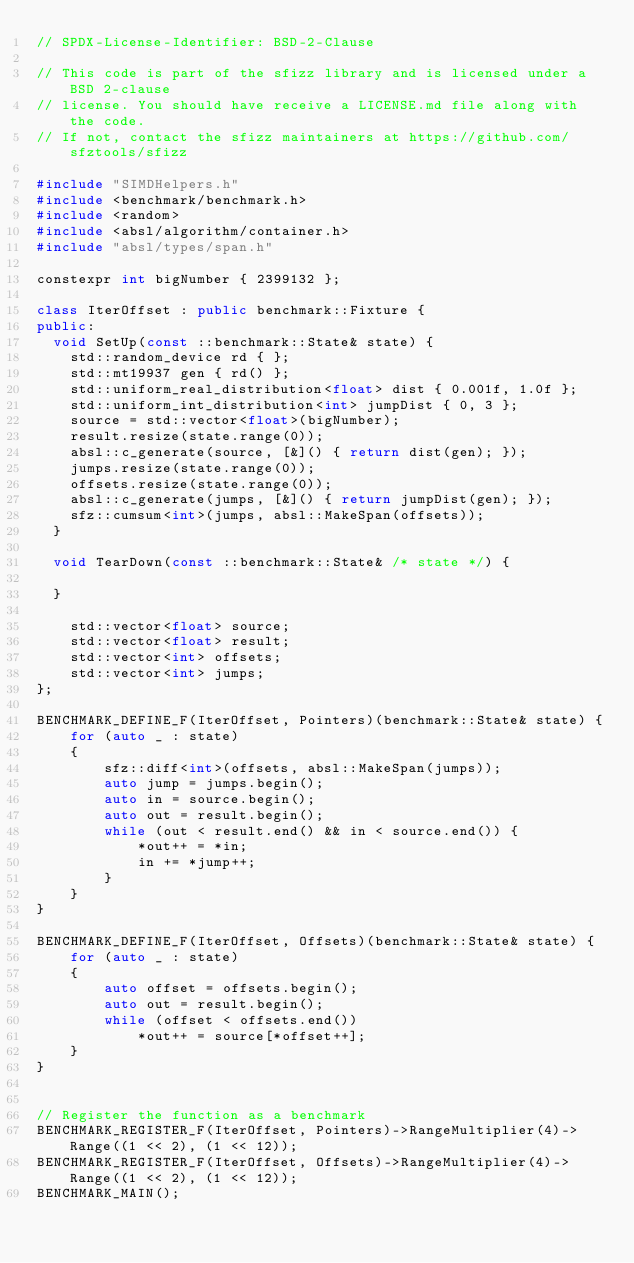<code> <loc_0><loc_0><loc_500><loc_500><_C++_>// SPDX-License-Identifier: BSD-2-Clause

// This code is part of the sfizz library and is licensed under a BSD 2-clause
// license. You should have receive a LICENSE.md file along with the code.
// If not, contact the sfizz maintainers at https://github.com/sfztools/sfizz

#include "SIMDHelpers.h"
#include <benchmark/benchmark.h>
#include <random>
#include <absl/algorithm/container.h>
#include "absl/types/span.h"

constexpr int bigNumber { 2399132 };

class IterOffset : public benchmark::Fixture {
public:
  void SetUp(const ::benchmark::State& state) {
    std::random_device rd { };
    std::mt19937 gen { rd() };
    std::uniform_real_distribution<float> dist { 0.001f, 1.0f };
    std::uniform_int_distribution<int> jumpDist { 0, 3 };
    source = std::vector<float>(bigNumber);
    result.resize(state.range(0));
    absl::c_generate(source, [&]() { return dist(gen); });
    jumps.resize(state.range(0));
    offsets.resize(state.range(0));
    absl::c_generate(jumps, [&]() { return jumpDist(gen); });
    sfz::cumsum<int>(jumps, absl::MakeSpan(offsets));
  }

  void TearDown(const ::benchmark::State& /* state */) {

  }

    std::vector<float> source;
    std::vector<float> result;
    std::vector<int> offsets;
    std::vector<int> jumps;
};

BENCHMARK_DEFINE_F(IterOffset, Pointers)(benchmark::State& state) {
    for (auto _ : state)
    {
        sfz::diff<int>(offsets, absl::MakeSpan(jumps));
        auto jump = jumps.begin();
        auto in = source.begin();
        auto out = result.begin();
        while (out < result.end() && in < source.end()) {
            *out++ = *in;
            in += *jump++;
        }
    }
}

BENCHMARK_DEFINE_F(IterOffset, Offsets)(benchmark::State& state) {
    for (auto _ : state)
    {
        auto offset = offsets.begin();
        auto out = result.begin();
        while (offset < offsets.end())
            *out++ = source[*offset++];
    }
}


// Register the function as a benchmark
BENCHMARK_REGISTER_F(IterOffset, Pointers)->RangeMultiplier(4)->Range((1 << 2), (1 << 12));
BENCHMARK_REGISTER_F(IterOffset, Offsets)->RangeMultiplier(4)->Range((1 << 2), (1 << 12));
BENCHMARK_MAIN();
</code> 